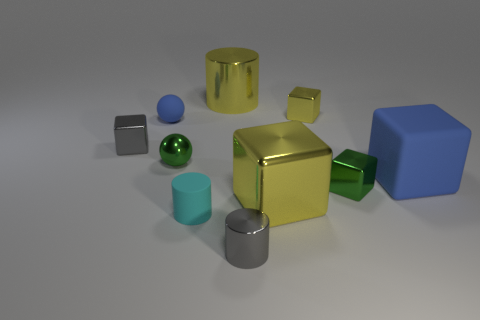There is a large object left of the gray metallic thing on the right side of the metallic block to the left of the tiny rubber cylinder; what is its color?
Offer a terse response. Yellow. There is a big object that is made of the same material as the yellow cylinder; what color is it?
Provide a succinct answer. Yellow. What number of other blocks have the same material as the gray block?
Ensure brevity in your answer.  3. There is a blue rubber object that is behind the green metal ball; does it have the same size as the green metallic ball?
Give a very brief answer. Yes. There is a shiny cylinder that is the same size as the blue matte sphere; what color is it?
Offer a terse response. Gray. There is a tiny metallic ball; what number of green metal things are in front of it?
Provide a short and direct response. 1. Are there any tiny rubber balls?
Make the answer very short. Yes. What is the size of the shiny cylinder that is behind the small gray object left of the object that is in front of the cyan matte object?
Your answer should be compact. Large. How many other things are there of the same size as the green sphere?
Keep it short and to the point. 6. There is a yellow thing behind the small yellow metal object; how big is it?
Provide a succinct answer. Large. 